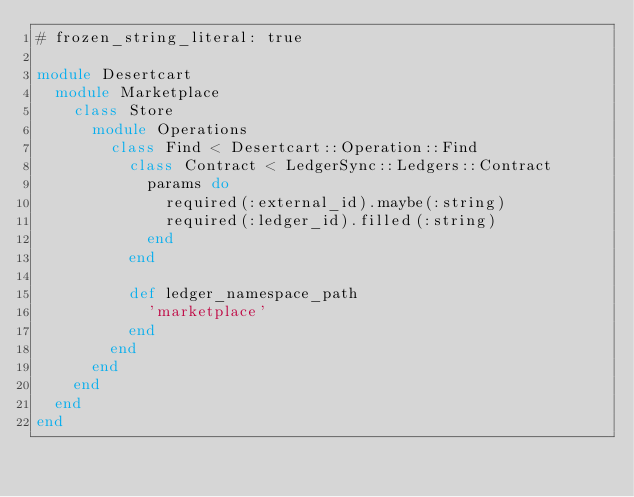<code> <loc_0><loc_0><loc_500><loc_500><_Ruby_># frozen_string_literal: true

module Desertcart
  module Marketplace
    class Store
      module Operations
        class Find < Desertcart::Operation::Find
          class Contract < LedgerSync::Ledgers::Contract
            params do
              required(:external_id).maybe(:string)
              required(:ledger_id).filled(:string)
            end
          end

          def ledger_namespace_path
            'marketplace'
          end
        end
      end
    end
  end
end
</code> 